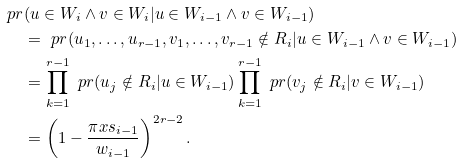Convert formula to latex. <formula><loc_0><loc_0><loc_500><loc_500>\ p r & ( u \in W _ { i } \wedge v \in W _ { i } | u \in W _ { i - 1 } \wedge v \in W _ { i - 1 } ) \\ & = \ p r ( u _ { 1 } , \dots , u _ { r - 1 } , v _ { 1 } , \dots , v _ { r - 1 } \notin R _ { i } | u \in W _ { i - 1 } \wedge v \in W _ { i - 1 } ) \\ & = \prod _ { k = 1 } ^ { r - 1 } \ p r ( u _ { j } \notin R _ { i } | u \in W _ { i - 1 } ) \prod _ { k = 1 } ^ { r - 1 } \ p r ( v _ { j } \notin R _ { i } | v \in W _ { i - 1 } ) \\ & = \left ( 1 - \frac { \pi x s _ { i - 1 } } { w _ { i - 1 } } \right ) ^ { 2 r - 2 } .</formula> 